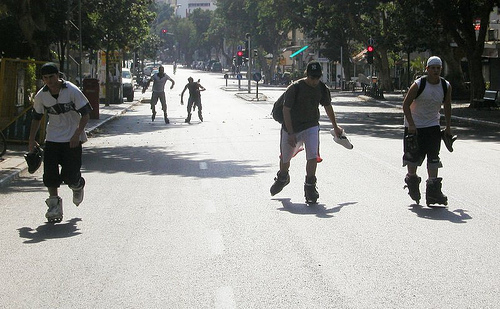Besides recreation, in what other ways can rollerblading be beneficial? Rollerblading offers a range of benefits beyond recreation; it's an excellent cardiovascular workout that can improve endurance and strength, particularly in the lower body. Additionally, it can enhance balance and coordination, and it provides an enjoyable way to travel short distances without contributing to traffic or pollution. 